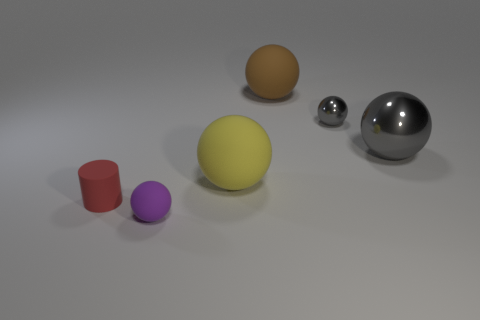What is the material of the other gray thing that is the same shape as the large metal object? The other gray object, which has the same spherical shape as the large metal sphere, appears to be made of a material with similar reflective properties, suggesting that it could also be a type of metal, although a definitive assessment would require physical examination or further context. 